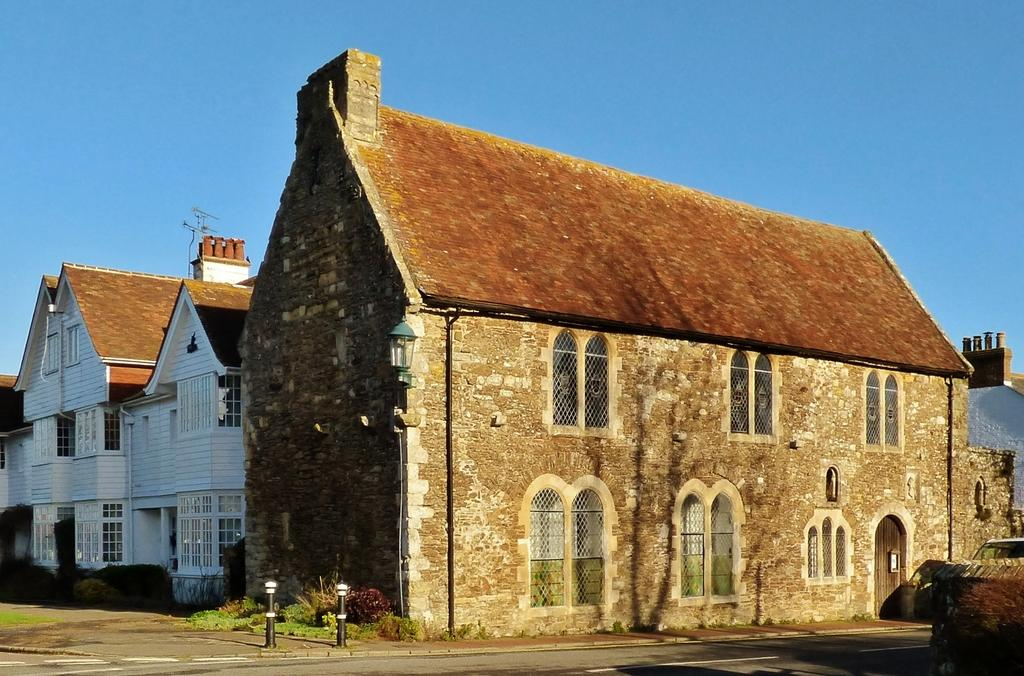What type of structures are present in the image? There are buildings in the image. What can be seen at the bottom of the image? There are poles at the bottom of the image. What part of the natural environment is visible in the image? The sky is visible in the background of the image. What type of crib is featured in the image? There is no crib present in the image. Who is sitting on the throne in the image? There is no throne present in the image. 